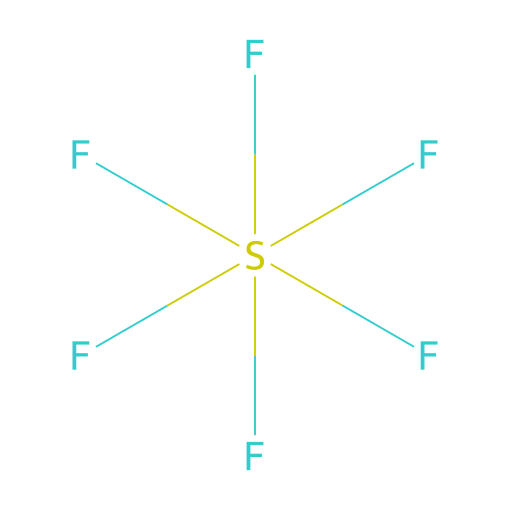What is the chemical name of this compound? The structure represents sulfur hexafluoride, as indicated by the sulfur (S) atom surrounded by six fluorine (F) atoms. The name reflects the number of fluorine atoms bonded to the sulfur.
Answer: sulfur hexafluoride How many fluorine atoms are present? The SMILES representation shows six F atoms directly bonded to the S atom, indicating there are six fluorine atoms in total.
Answer: six What type of bonds are present in the structure? The structure consists of single covalent bonds between the sulfur and each fluorine atom, indicated by the lack of any double or triple bond symbols in the SMILES notation.
Answer: single Is this compound polar or nonpolar? The molecule is nonpolar because of its symmetrical octahedral geometry, which allows for even distribution of charge among the fluorine atoms surrounding the sulfur atom.
Answer: nonpolar Why is sulfur hexafluoride used in sound systems? Its unique property of being an inert and heavy gas leads to improved sound insulation and allows for different sound effects without being reactive in the environment where used.
Answer: sound insulation 